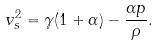Convert formula to latex. <formula><loc_0><loc_0><loc_500><loc_500>v _ { s } ^ { 2 } = \gamma ( 1 + \alpha ) - \frac { \alpha p } { \rho } .</formula> 